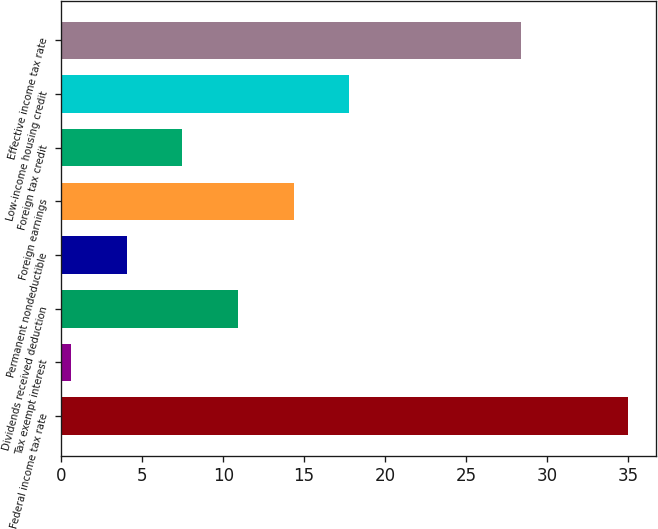<chart> <loc_0><loc_0><loc_500><loc_500><bar_chart><fcel>Federal income tax rate<fcel>Tax exempt interest<fcel>Dividends received deduction<fcel>Permanent nondeductible<fcel>Foreign earnings<fcel>Foreign tax credit<fcel>Low-income housing credit<fcel>Effective income tax rate<nl><fcel>35<fcel>0.6<fcel>10.92<fcel>4.04<fcel>14.36<fcel>7.48<fcel>17.8<fcel>28.4<nl></chart> 